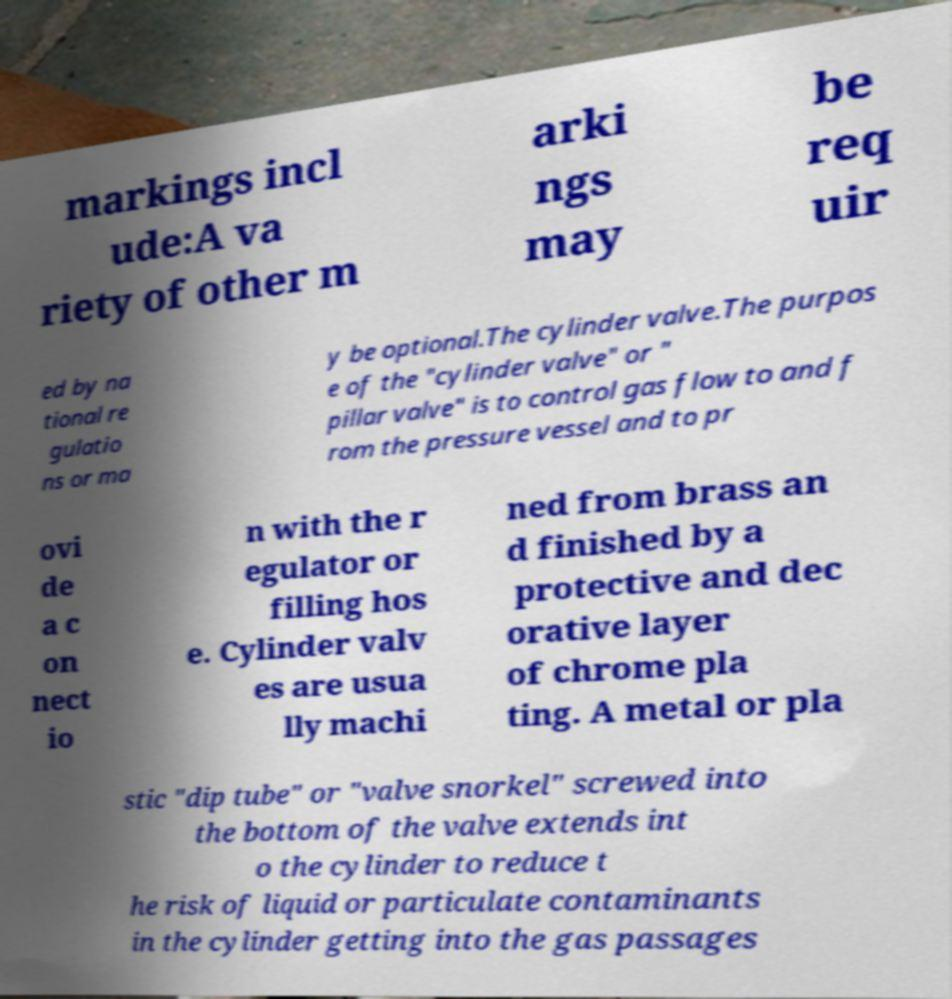Can you read and provide the text displayed in the image?This photo seems to have some interesting text. Can you extract and type it out for me? markings incl ude:A va riety of other m arki ngs may be req uir ed by na tional re gulatio ns or ma y be optional.The cylinder valve.The purpos e of the "cylinder valve" or " pillar valve" is to control gas flow to and f rom the pressure vessel and to pr ovi de a c on nect io n with the r egulator or filling hos e. Cylinder valv es are usua lly machi ned from brass an d finished by a protective and dec orative layer of chrome pla ting. A metal or pla stic "dip tube" or "valve snorkel" screwed into the bottom of the valve extends int o the cylinder to reduce t he risk of liquid or particulate contaminants in the cylinder getting into the gas passages 